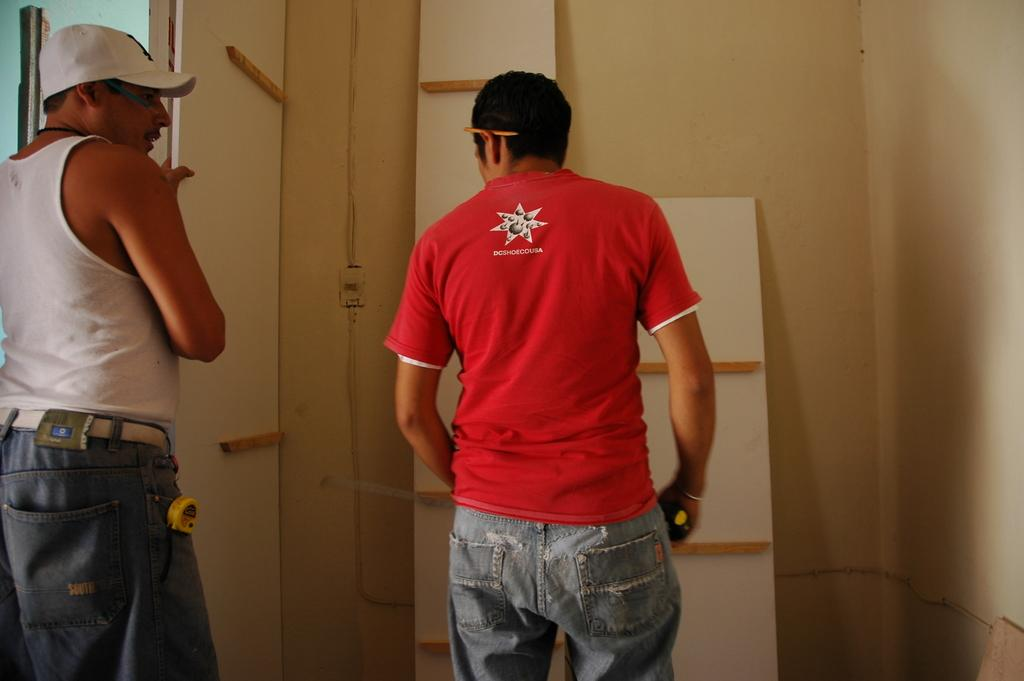How many people are in the image? There are two people standing in the image. Can you describe the clothing of one of the people? One person is wearing a red shirt and jeans. What is the color of the board in the image? There is a white color board in the image. What is the color of the wall in the image? There is a cream-colored wall in the image. How many grapes are on the white color board in the image? There are no grapes present on the white color board in the image. What type of bomb is depicted on the cream-colored wall in the image? There is no bomb depicted on the cream-colored wall in the image. 